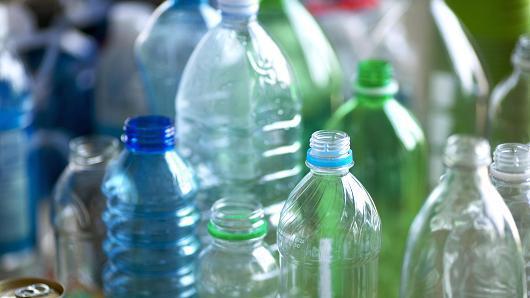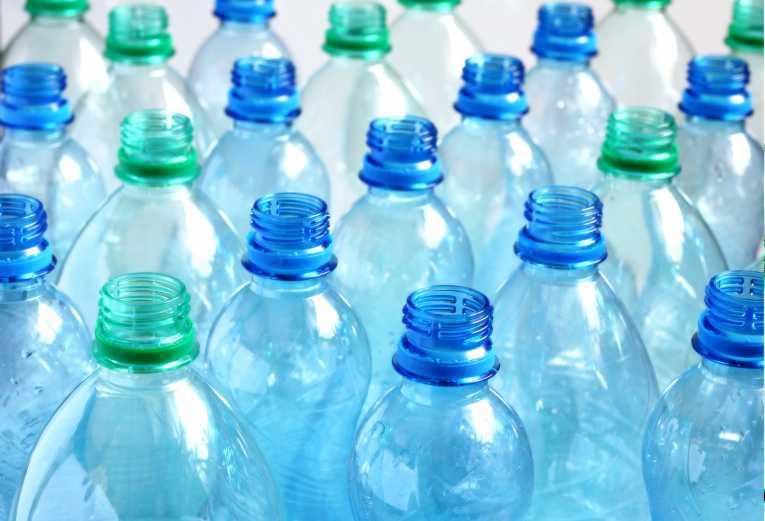The first image is the image on the left, the second image is the image on the right. For the images displayed, is the sentence "The right image depicts refillable sport-type water bottles." factually correct? Answer yes or no. No. The first image is the image on the left, the second image is the image on the right. Evaluate the accuracy of this statement regarding the images: "One image is of many rows of plastic water bottles with plastic caps.". Is it true? Answer yes or no. No. 